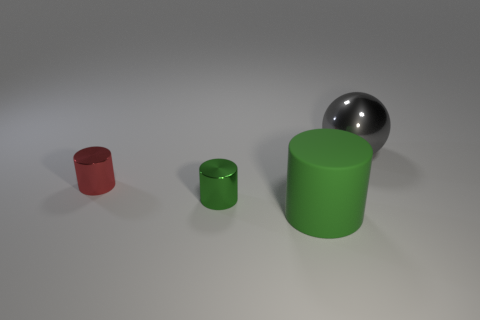How many red cylinders are the same size as the green shiny cylinder?
Your answer should be very brief. 1. There is a green object behind the green matte object; is its size the same as the thing that is behind the small red thing?
Ensure brevity in your answer.  No. There is a metal thing that is behind the tiny red metal thing; what is its shape?
Your response must be concise. Sphere. What material is the big object that is to the left of the large thing that is behind the large green cylinder made of?
Your answer should be compact. Rubber. Are there any objects that have the same color as the sphere?
Give a very brief answer. No. Does the sphere have the same size as the green cylinder that is behind the green matte cylinder?
Keep it short and to the point. No. There is a green thing behind the large thing that is in front of the gray metallic object; how many red metal cylinders are in front of it?
Make the answer very short. 0. How many metal cylinders are to the left of the rubber cylinder?
Keep it short and to the point. 2. The large thing that is left of the big shiny object on the right side of the large green rubber object is what color?
Offer a very short reply. Green. What number of other objects are there of the same material as the red cylinder?
Provide a succinct answer. 2. 